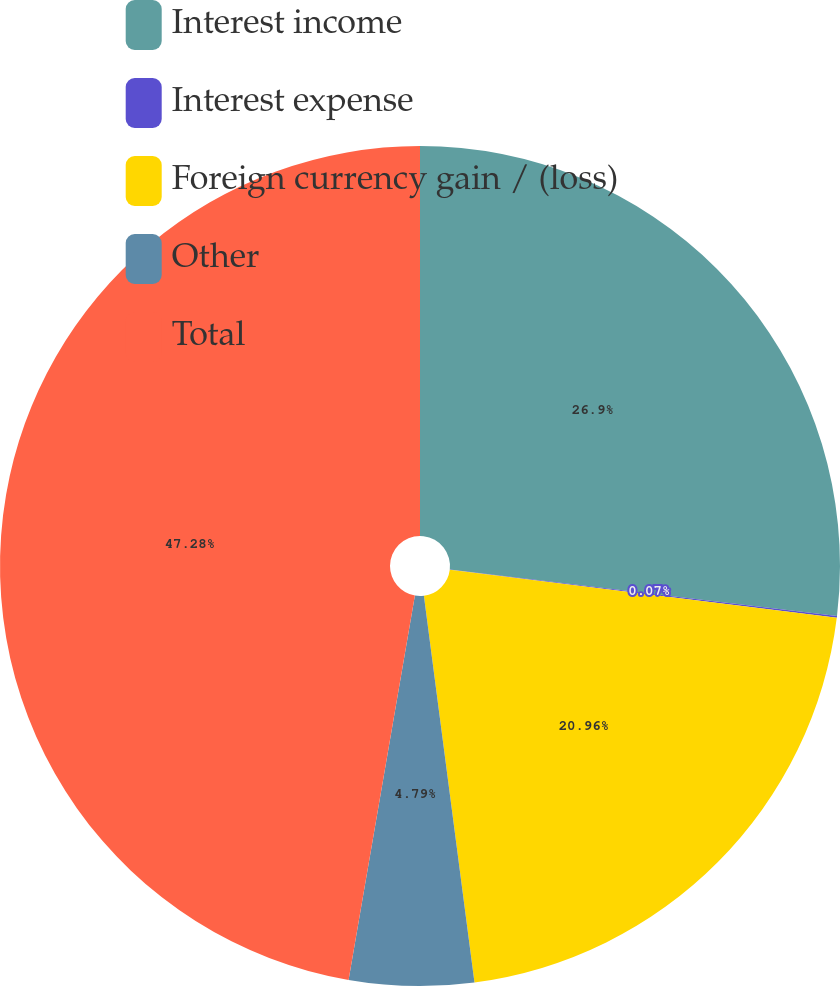<chart> <loc_0><loc_0><loc_500><loc_500><pie_chart><fcel>Interest income<fcel>Interest expense<fcel>Foreign currency gain / (loss)<fcel>Other<fcel>Total<nl><fcel>26.9%<fcel>0.07%<fcel>20.96%<fcel>4.79%<fcel>47.28%<nl></chart> 